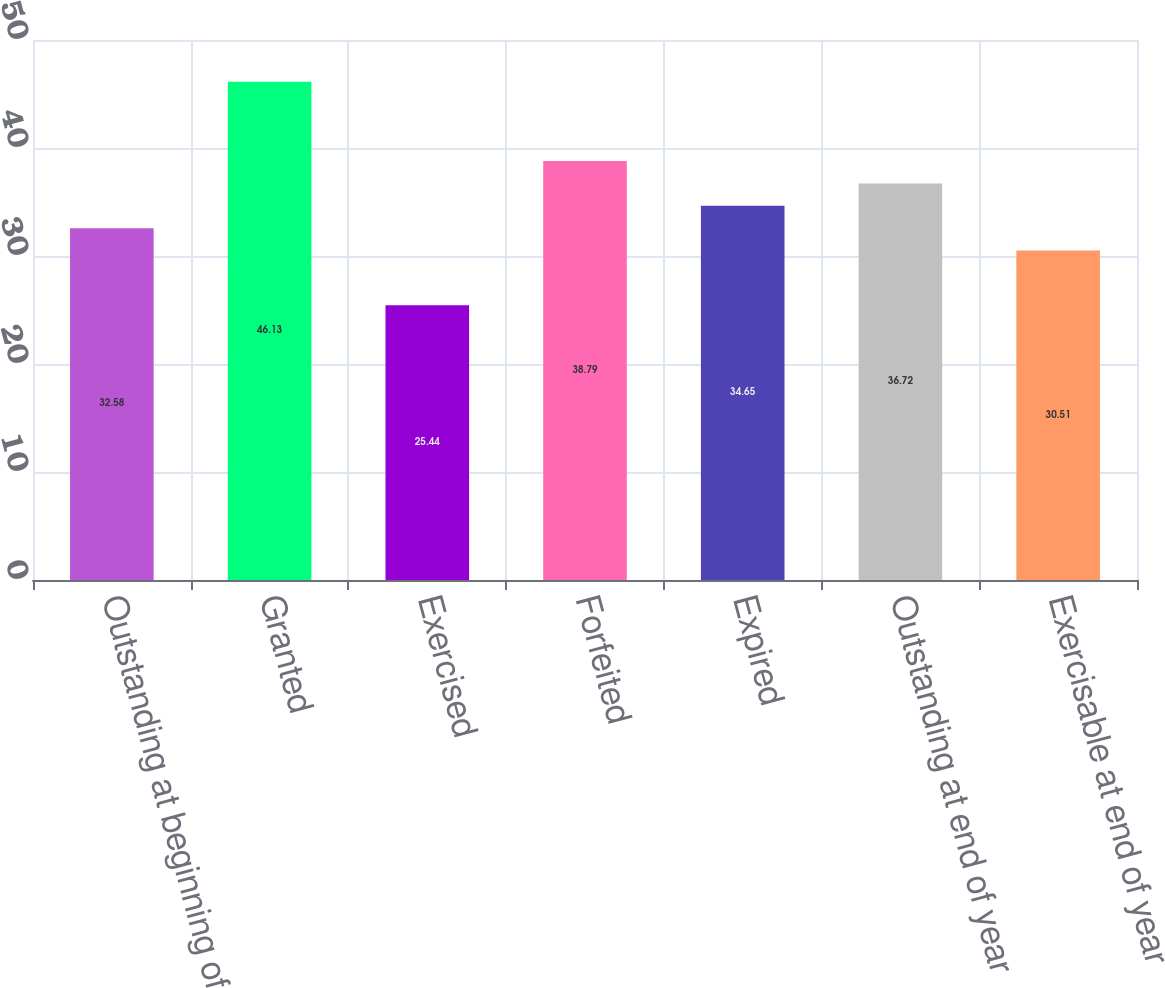Convert chart. <chart><loc_0><loc_0><loc_500><loc_500><bar_chart><fcel>Outstanding at beginning of<fcel>Granted<fcel>Exercised<fcel>Forfeited<fcel>Expired<fcel>Outstanding at end of year<fcel>Exercisable at end of year<nl><fcel>32.58<fcel>46.13<fcel>25.44<fcel>38.79<fcel>34.65<fcel>36.72<fcel>30.51<nl></chart> 